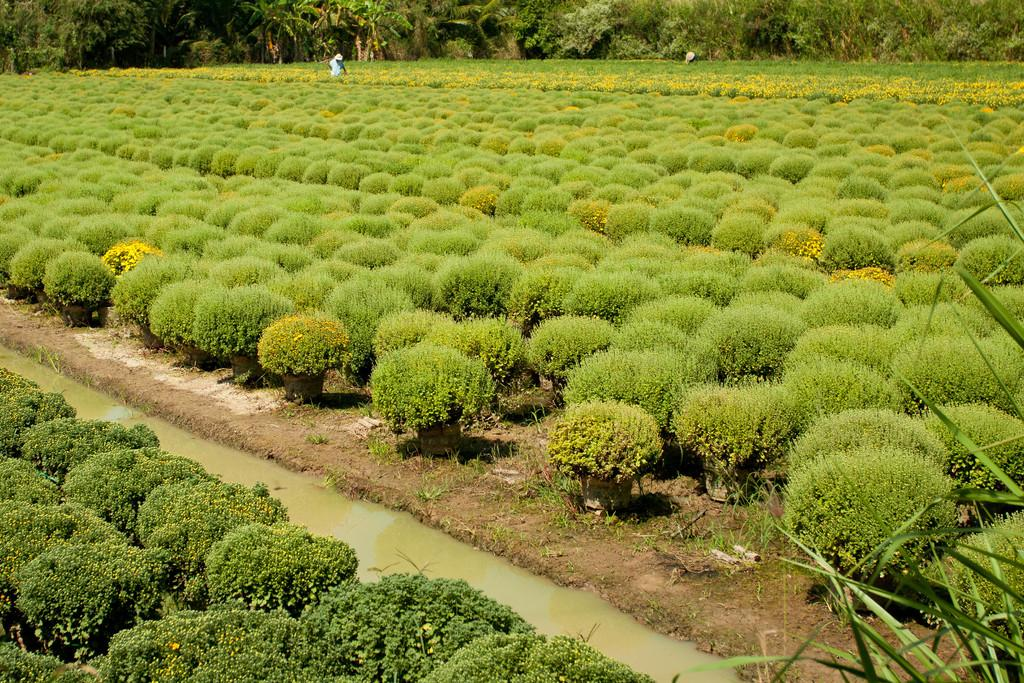What type of objects are present in the image? There are many potted plants in the image. What can be seen on the ground in the middle of the image? There is water on the ground in the middle of the image. Are there any text or writing on any of the objects in the image? No, there is no writing or text on any of the objects in the image. What is visible in the background of the image? There are trees in the background of the image. Can you describe the human figure in the image? Yes, there is a human figure in the middle of the image. How many snakes are wrapped around the human figure in the image? There are no snakes present in the image; it only features potted plants, water, trees, and a human figure. 